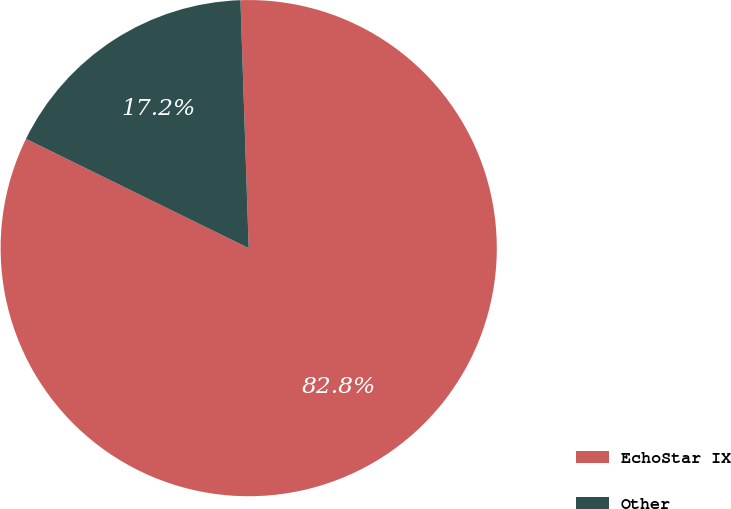Convert chart. <chart><loc_0><loc_0><loc_500><loc_500><pie_chart><fcel>EchoStar IX<fcel>Other<nl><fcel>82.79%<fcel>17.21%<nl></chart> 